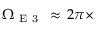Convert formula to latex. <formula><loc_0><loc_0><loc_500><loc_500>\Omega _ { E 3 } \, \approx \, 2 \pi \times</formula> 